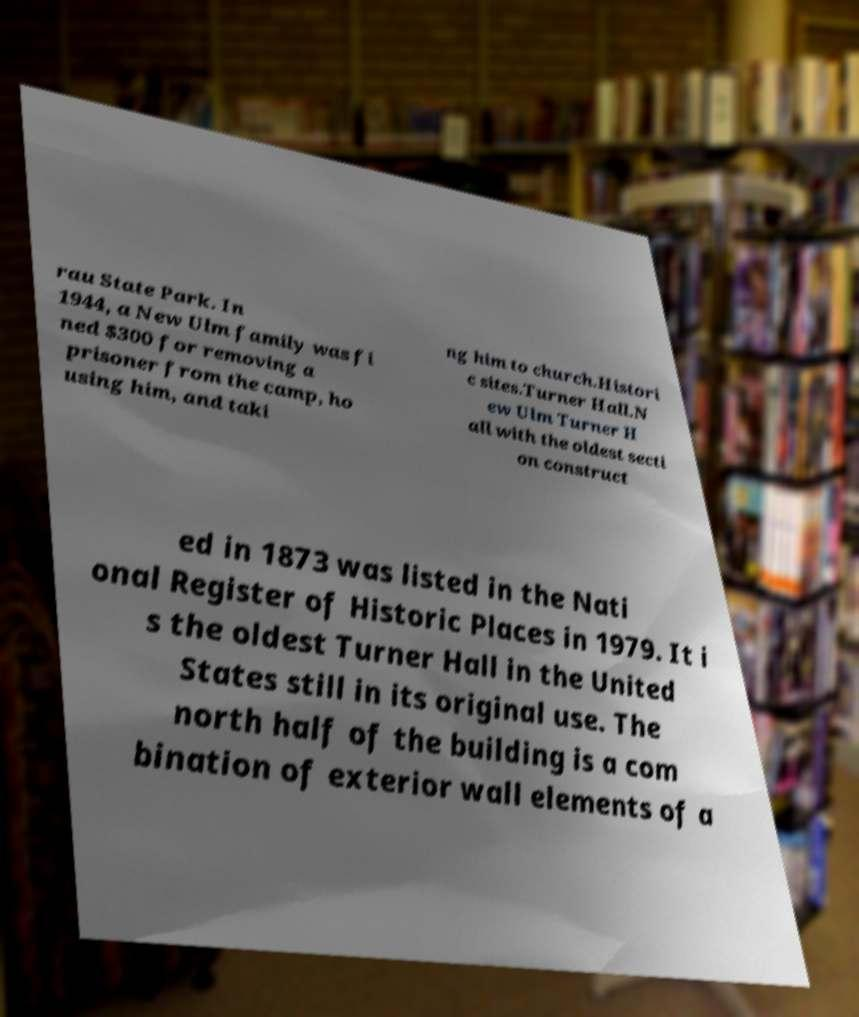Could you assist in decoding the text presented in this image and type it out clearly? rau State Park. In 1944, a New Ulm family was fi ned $300 for removing a prisoner from the camp, ho using him, and taki ng him to church.Histori c sites.Turner Hall.N ew Ulm Turner H all with the oldest secti on construct ed in 1873 was listed in the Nati onal Register of Historic Places in 1979. It i s the oldest Turner Hall in the United States still in its original use. The north half of the building is a com bination of exterior wall elements of a 